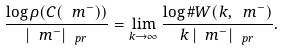<formula> <loc_0><loc_0><loc_500><loc_500>\frac { \log \rho ( C ( \ m ^ { - } ) ) } { | \ m ^ { - } | _ { \ p r } } = \lim _ { k \to \infty } \frac { \log \# W ( k , \ m ^ { - } ) } { k \, | \ m ^ { - } | _ { \ p r } } .</formula> 